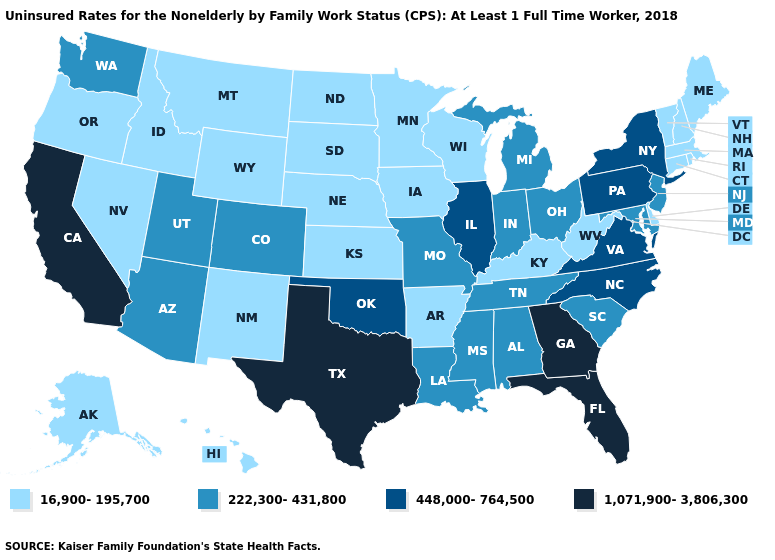What is the value of Connecticut?
Write a very short answer. 16,900-195,700. What is the value of Michigan?
Write a very short answer. 222,300-431,800. What is the value of Oklahoma?
Answer briefly. 448,000-764,500. Does the first symbol in the legend represent the smallest category?
Concise answer only. Yes. What is the value of South Dakota?
Be succinct. 16,900-195,700. What is the value of Missouri?
Answer briefly. 222,300-431,800. Which states have the lowest value in the MidWest?
Answer briefly. Iowa, Kansas, Minnesota, Nebraska, North Dakota, South Dakota, Wisconsin. Which states hav the highest value in the South?
Concise answer only. Florida, Georgia, Texas. What is the value of South Dakota?
Concise answer only. 16,900-195,700. What is the value of Virginia?
Write a very short answer. 448,000-764,500. Name the states that have a value in the range 222,300-431,800?
Short answer required. Alabama, Arizona, Colorado, Indiana, Louisiana, Maryland, Michigan, Mississippi, Missouri, New Jersey, Ohio, South Carolina, Tennessee, Utah, Washington. What is the highest value in the MidWest ?
Concise answer only. 448,000-764,500. Does Colorado have a lower value than Wyoming?
Quick response, please. No. 